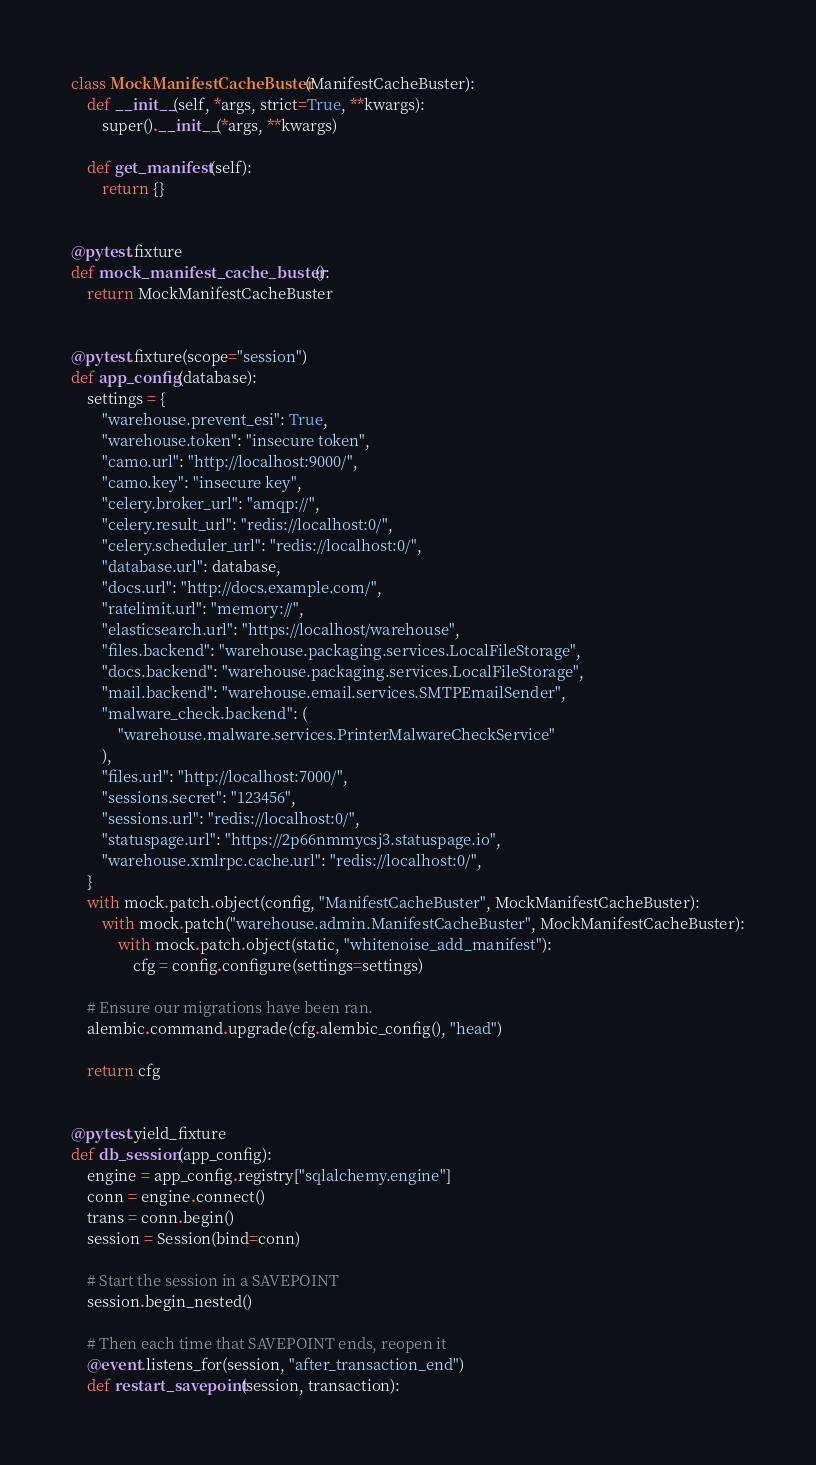Convert code to text. <code><loc_0><loc_0><loc_500><loc_500><_Python_>

class MockManifestCacheBuster(ManifestCacheBuster):
    def __init__(self, *args, strict=True, **kwargs):
        super().__init__(*args, **kwargs)

    def get_manifest(self):
        return {}


@pytest.fixture
def mock_manifest_cache_buster():
    return MockManifestCacheBuster


@pytest.fixture(scope="session")
def app_config(database):
    settings = {
        "warehouse.prevent_esi": True,
        "warehouse.token": "insecure token",
        "camo.url": "http://localhost:9000/",
        "camo.key": "insecure key",
        "celery.broker_url": "amqp://",
        "celery.result_url": "redis://localhost:0/",
        "celery.scheduler_url": "redis://localhost:0/",
        "database.url": database,
        "docs.url": "http://docs.example.com/",
        "ratelimit.url": "memory://",
        "elasticsearch.url": "https://localhost/warehouse",
        "files.backend": "warehouse.packaging.services.LocalFileStorage",
        "docs.backend": "warehouse.packaging.services.LocalFileStorage",
        "mail.backend": "warehouse.email.services.SMTPEmailSender",
        "malware_check.backend": (
            "warehouse.malware.services.PrinterMalwareCheckService"
        ),
        "files.url": "http://localhost:7000/",
        "sessions.secret": "123456",
        "sessions.url": "redis://localhost:0/",
        "statuspage.url": "https://2p66nmmycsj3.statuspage.io",
        "warehouse.xmlrpc.cache.url": "redis://localhost:0/",
    }
    with mock.patch.object(config, "ManifestCacheBuster", MockManifestCacheBuster):
        with mock.patch("warehouse.admin.ManifestCacheBuster", MockManifestCacheBuster):
            with mock.patch.object(static, "whitenoise_add_manifest"):
                cfg = config.configure(settings=settings)

    # Ensure our migrations have been ran.
    alembic.command.upgrade(cfg.alembic_config(), "head")

    return cfg


@pytest.yield_fixture
def db_session(app_config):
    engine = app_config.registry["sqlalchemy.engine"]
    conn = engine.connect()
    trans = conn.begin()
    session = Session(bind=conn)

    # Start the session in a SAVEPOINT
    session.begin_nested()

    # Then each time that SAVEPOINT ends, reopen it
    @event.listens_for(session, "after_transaction_end")
    def restart_savepoint(session, transaction):</code> 